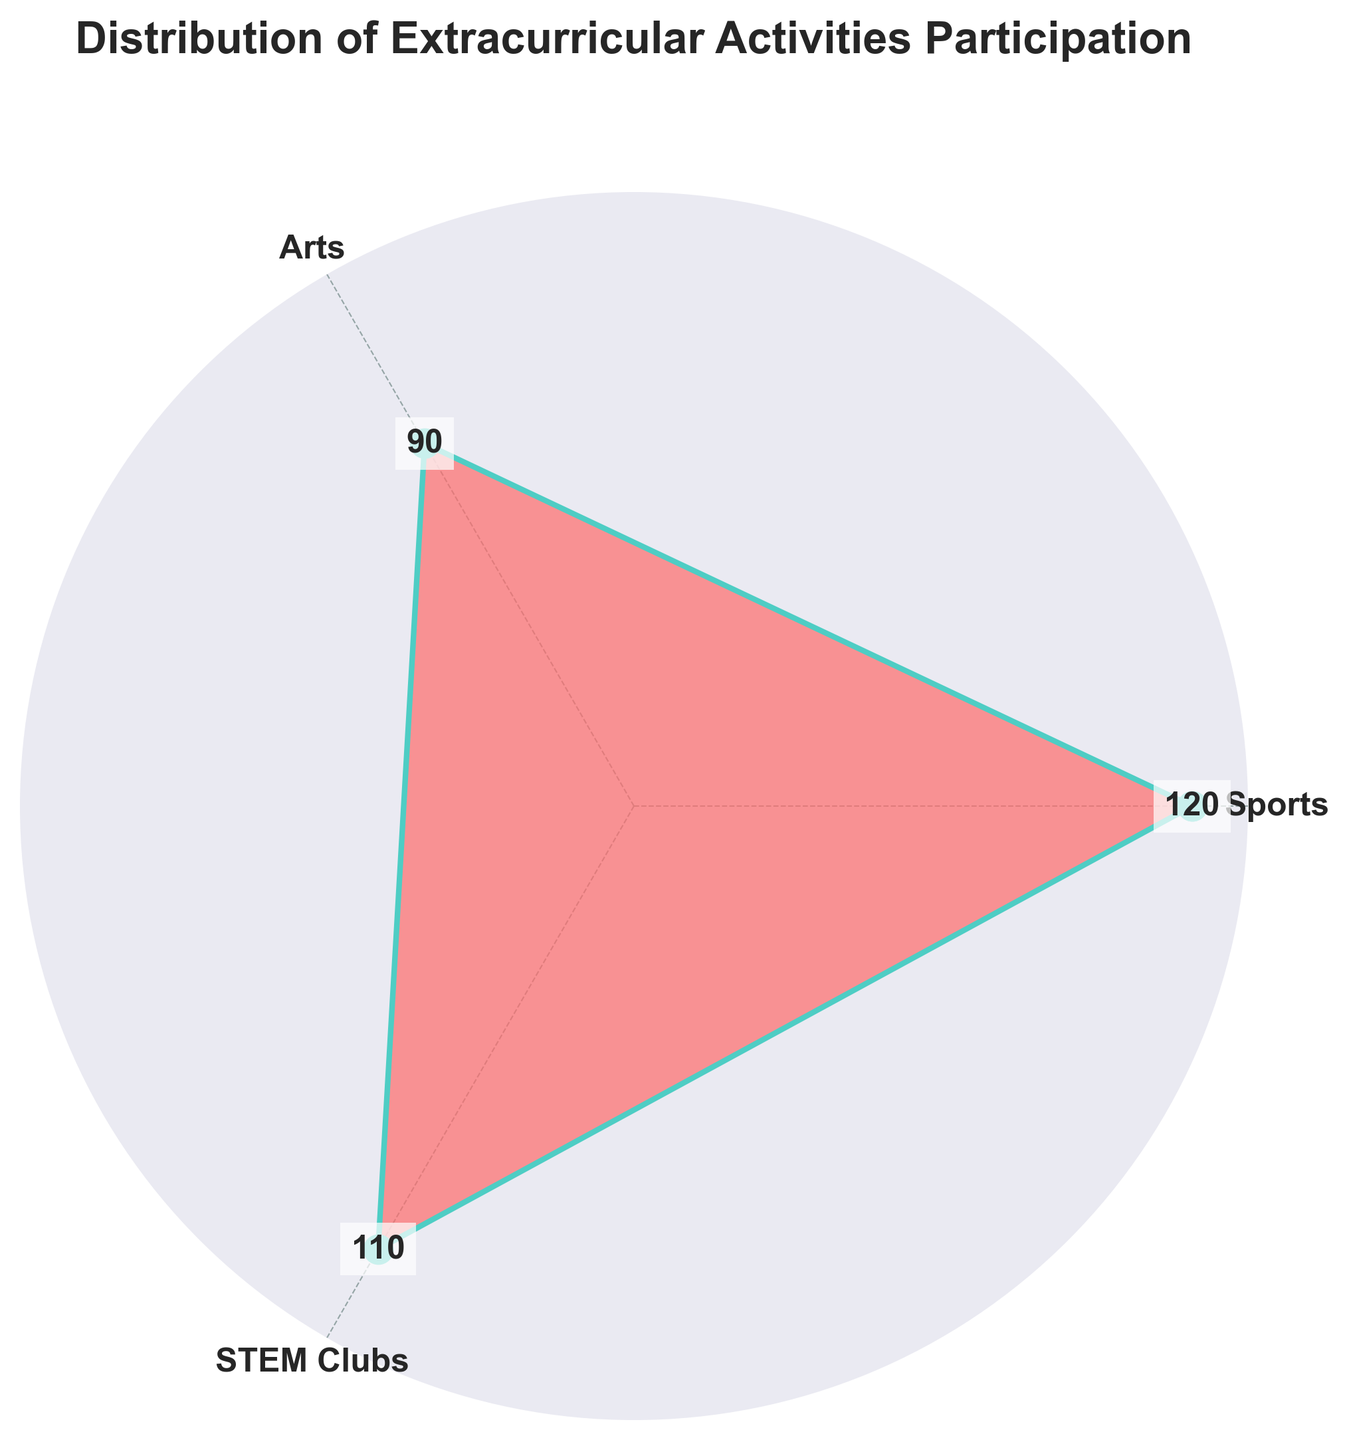What is the title of the chart? The title is written above the chart and summarizes what the chart represents.
Answer: Distribution of Extracurricular Activities Participation Which activity has the highest participation count? The length of the segment for each activity represents participation; the longest segment indicates the highest count.
Answer: Sports How many more students participate in sports compared to arts? Compare the lengths of the segments for sports and arts; the difference is the number of additional students.
Answer: 30 Which two activities have the closest participation counts? Compare the segment lengths and find the two with the smallest difference in length.
Answer: Sports and STEM Clubs What is the total number of students participating in these extracurricular activities? Sum the participation counts from all segments. 120 (Sports) + 90 (Arts) + 110 (STEM Clubs)
Answer: 320 What percentage of students participate in STEM Clubs? Divide the STEM Clubs participation count by the total number of students and multiply by 100. (110 / 320) * 100
Answer: 34.38% Which activity has the smallest segment in the chart? Identify the shortest segment in the chart, which corresponds to the activity with the least participation.
Answer: Arts How does the sport participation compare to the combined participation of Arts and STEM Clubs? Add the participation counts for Arts and STEM Clubs and compare this sum to the participation count for Sports. 90 (Arts) + 110 (STEM Clubs) = 200, which is more than 120 (Sports)
Answer: Less How much greater is the combined participation in Arts and STEM Clubs compared to Sports? Subtract the sports participation count from the combined count of Arts and STEM Clubs. 200 (Arts + STEM Clubs) - 120 (Sports)
Answer: 80 Is there an equal gap in participation counts between each category? Compare the differences between participation counts of each pair of activities. Sports to Arts is 30. Arts to STEM Clubs is 20. Sports to STEM Clubs is 10. None of these gaps are equal.
Answer: No 